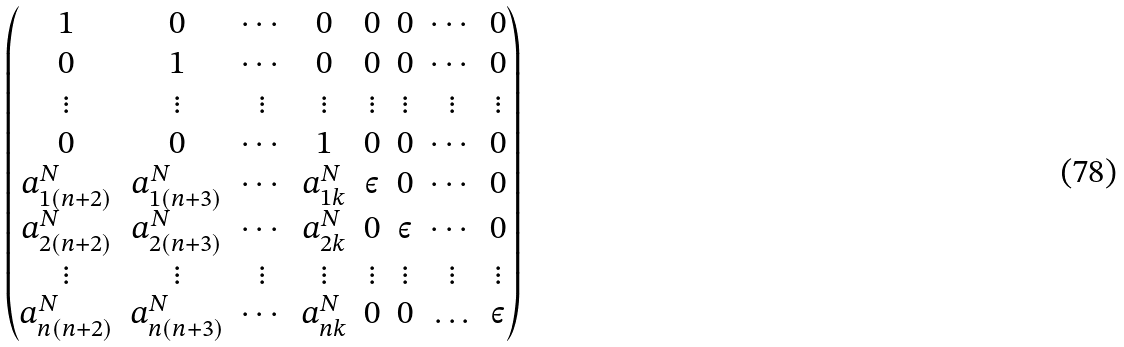<formula> <loc_0><loc_0><loc_500><loc_500>\begin{pmatrix} 1 & 0 & \cdots & 0 & 0 & 0 & \cdots & 0 \\ 0 & 1 & \cdots & 0 & 0 & 0 & \cdots & 0 \\ \vdots & \vdots & \vdots & \vdots & \vdots & \vdots & \vdots & \vdots \\ 0 & 0 & \cdots & 1 & 0 & 0 & \cdots & 0 \\ a ^ { N } _ { 1 ( n + 2 ) } & a ^ { N } _ { 1 ( n + 3 ) } & \cdots & a ^ { N } _ { 1 k } & \varepsilon & 0 & \cdots & 0 \\ a ^ { N } _ { 2 ( n + 2 ) } & a ^ { N } _ { 2 ( n + 3 ) } & \cdots & a ^ { N } _ { 2 k } & 0 & \varepsilon & \cdots & 0 \\ \vdots & \vdots & \vdots & \vdots & \vdots & \vdots & \vdots & \vdots \\ a ^ { N } _ { n ( n + 2 ) } & a ^ { N } _ { n ( n + 3 ) } & \cdots & a ^ { N } _ { n k } & 0 & 0 & \hdots & \varepsilon \end{pmatrix}</formula> 